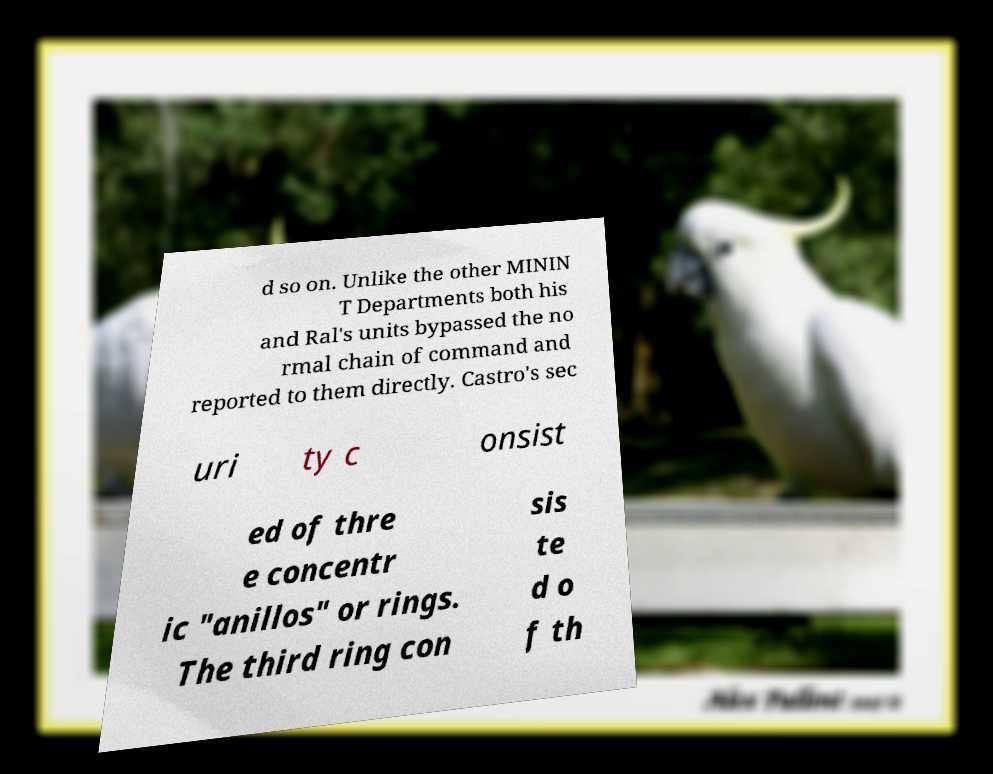Can you read and provide the text displayed in the image?This photo seems to have some interesting text. Can you extract and type it out for me? d so on. Unlike the other MININ T Departments both his and Ral's units bypassed the no rmal chain of command and reported to them directly. Castro's sec uri ty c onsist ed of thre e concentr ic "anillos" or rings. The third ring con sis te d o f th 